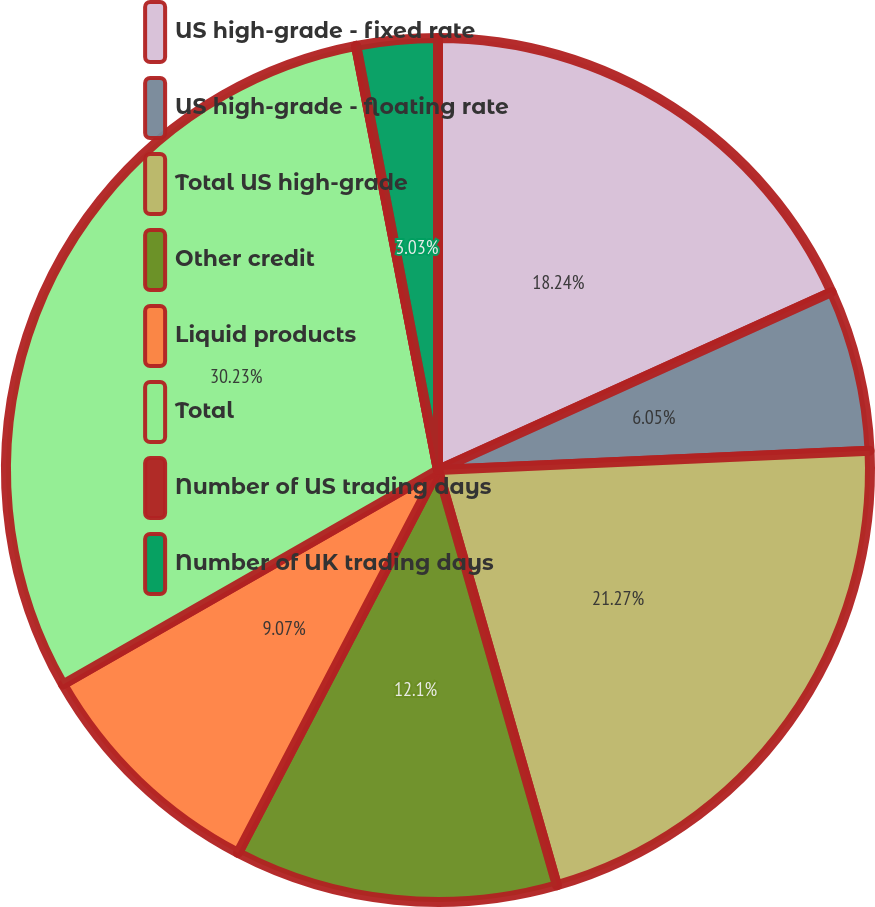Convert chart to OTSL. <chart><loc_0><loc_0><loc_500><loc_500><pie_chart><fcel>US high-grade - fixed rate<fcel>US high-grade - floating rate<fcel>Total US high-grade<fcel>Other credit<fcel>Liquid products<fcel>Total<fcel>Number of US trading days<fcel>Number of UK trading days<nl><fcel>18.24%<fcel>6.05%<fcel>21.27%<fcel>12.1%<fcel>9.07%<fcel>30.23%<fcel>0.01%<fcel>3.03%<nl></chart> 